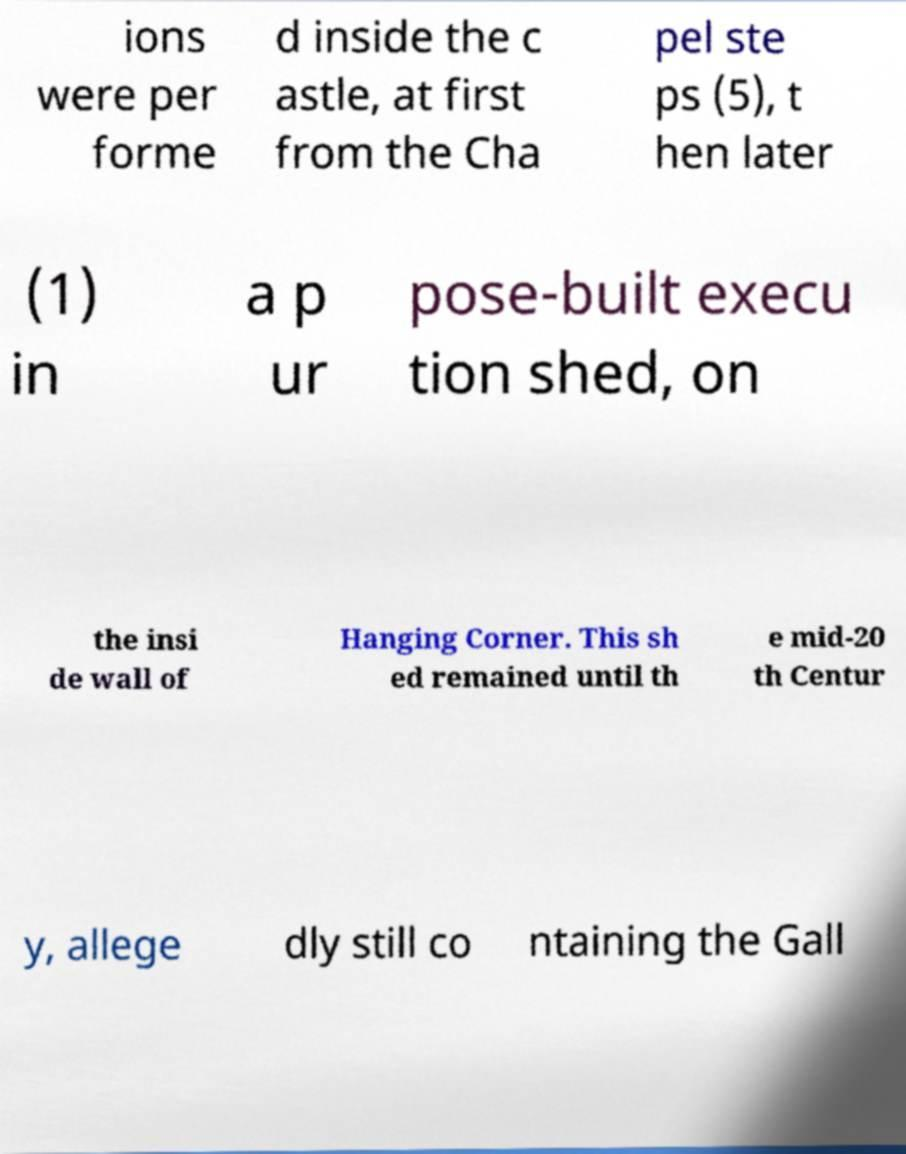Could you assist in decoding the text presented in this image and type it out clearly? ions were per forme d inside the c astle, at first from the Cha pel ste ps (5), t hen later (1) in a p ur pose-built execu tion shed, on the insi de wall of Hanging Corner. This sh ed remained until th e mid-20 th Centur y, allege dly still co ntaining the Gall 